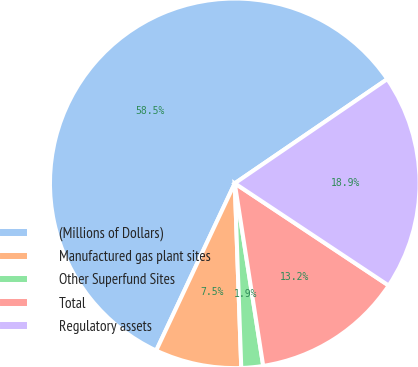<chart> <loc_0><loc_0><loc_500><loc_500><pie_chart><fcel>(Millions of Dollars)<fcel>Manufactured gas plant sites<fcel>Other Superfund Sites<fcel>Total<fcel>Regulatory assets<nl><fcel>58.47%<fcel>7.55%<fcel>1.9%<fcel>13.21%<fcel>18.87%<nl></chart> 